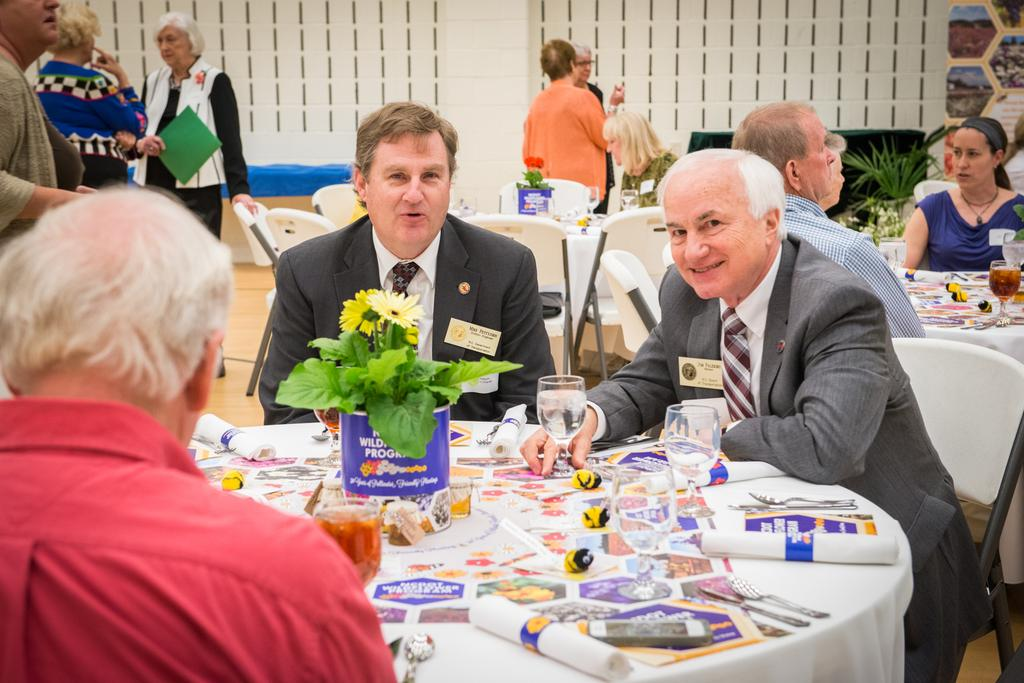How many people are sitting on a table in the image? There are three people sitting on a table in the image. What can be observed in the background of the image? In the background, there are many people sitting on tables and also people standing. What type of truck is being driven by the grandmother in the image? There is no truck or grandmother present in the image. 